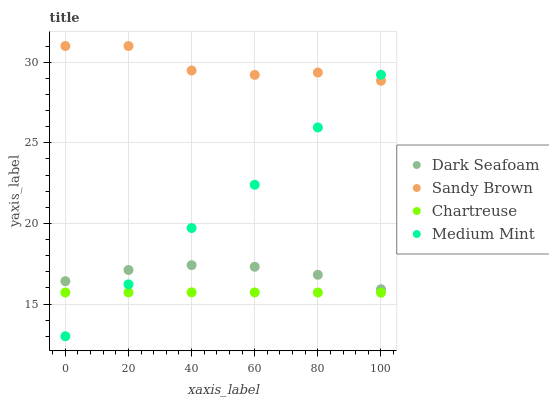Does Chartreuse have the minimum area under the curve?
Answer yes or no. Yes. Does Sandy Brown have the maximum area under the curve?
Answer yes or no. Yes. Does Dark Seafoam have the minimum area under the curve?
Answer yes or no. No. Does Dark Seafoam have the maximum area under the curve?
Answer yes or no. No. Is Chartreuse the smoothest?
Answer yes or no. Yes. Is Sandy Brown the roughest?
Answer yes or no. Yes. Is Dark Seafoam the smoothest?
Answer yes or no. No. Is Dark Seafoam the roughest?
Answer yes or no. No. Does Medium Mint have the lowest value?
Answer yes or no. Yes. Does Dark Seafoam have the lowest value?
Answer yes or no. No. Does Sandy Brown have the highest value?
Answer yes or no. Yes. Does Dark Seafoam have the highest value?
Answer yes or no. No. Is Chartreuse less than Sandy Brown?
Answer yes or no. Yes. Is Sandy Brown greater than Chartreuse?
Answer yes or no. Yes. Does Dark Seafoam intersect Medium Mint?
Answer yes or no. Yes. Is Dark Seafoam less than Medium Mint?
Answer yes or no. No. Is Dark Seafoam greater than Medium Mint?
Answer yes or no. No. Does Chartreuse intersect Sandy Brown?
Answer yes or no. No. 